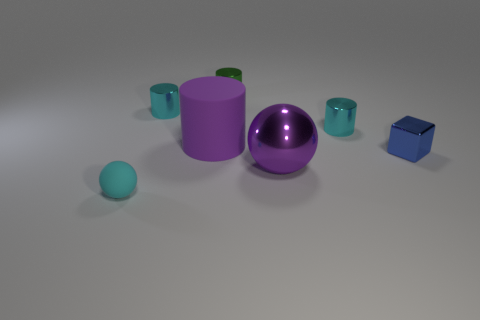What number of objects are big purple objects on the right side of the green thing or cyan rubber balls? 2 